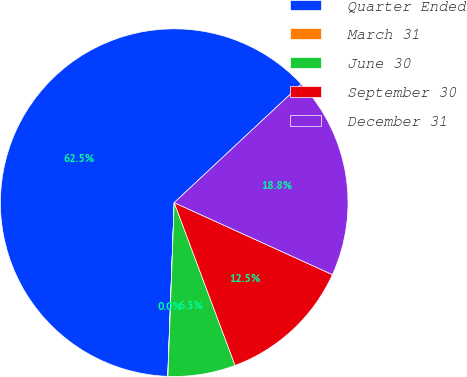<chart> <loc_0><loc_0><loc_500><loc_500><pie_chart><fcel>Quarter Ended<fcel>March 31<fcel>June 30<fcel>September 30<fcel>December 31<nl><fcel>62.45%<fcel>0.02%<fcel>6.27%<fcel>12.51%<fcel>18.75%<nl></chart> 